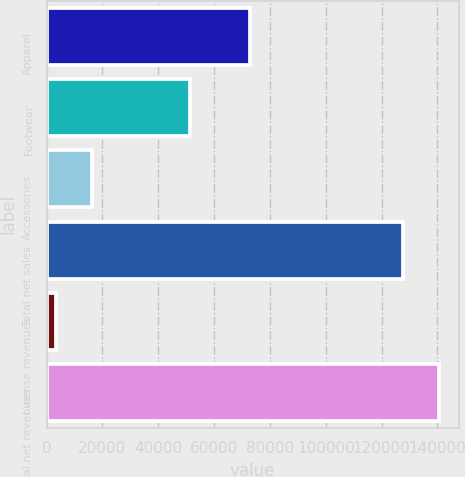<chart> <loc_0><loc_0><loc_500><loc_500><bar_chart><fcel>Apparel<fcel>Footwear<fcel>Accessories<fcel>Total net sales<fcel>License revenues<fcel>Total net revenues<nl><fcel>72892<fcel>51376<fcel>16148.8<fcel>127798<fcel>3369<fcel>140578<nl></chart> 